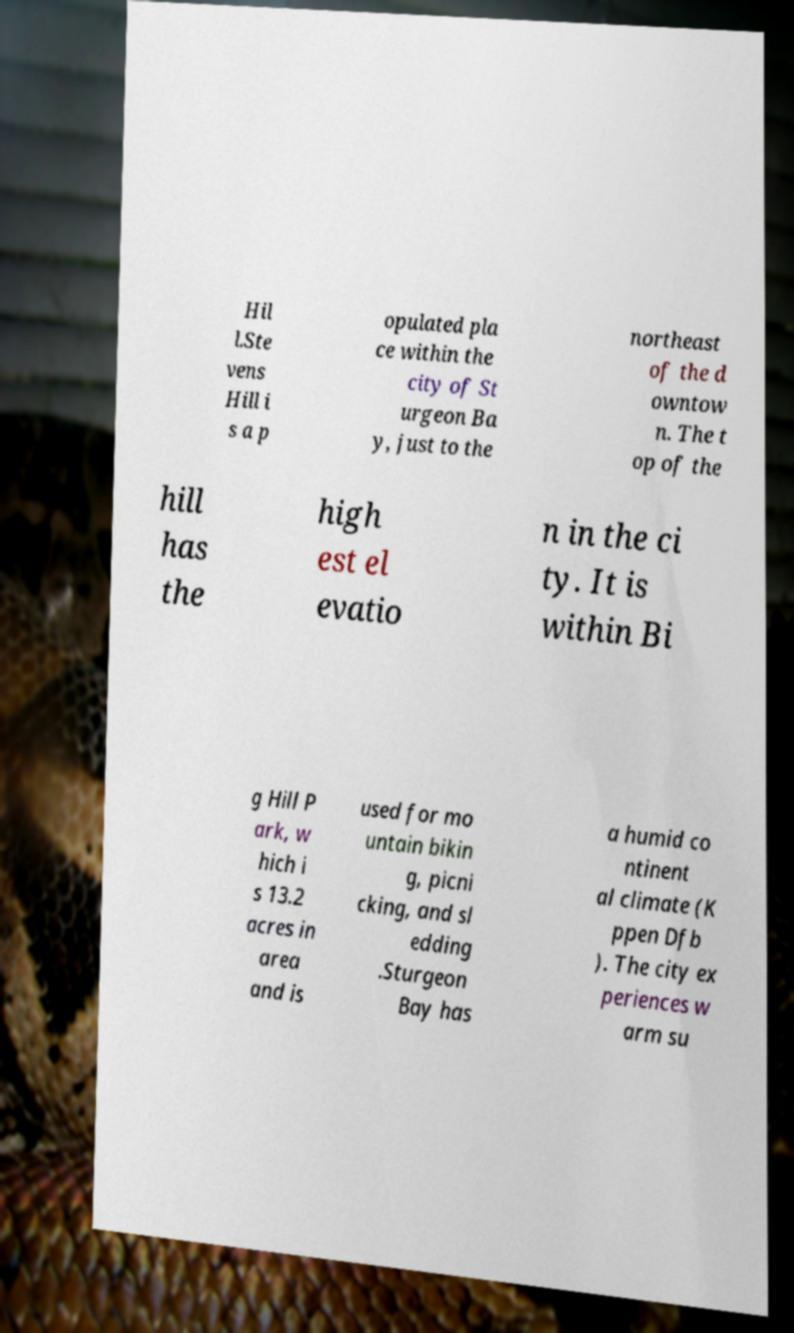Can you read and provide the text displayed in the image?This photo seems to have some interesting text. Can you extract and type it out for me? Hil l.Ste vens Hill i s a p opulated pla ce within the city of St urgeon Ba y, just to the northeast of the d owntow n. The t op of the hill has the high est el evatio n in the ci ty. It is within Bi g Hill P ark, w hich i s 13.2 acres in area and is used for mo untain bikin g, picni cking, and sl edding .Sturgeon Bay has a humid co ntinent al climate (K ppen Dfb ). The city ex periences w arm su 